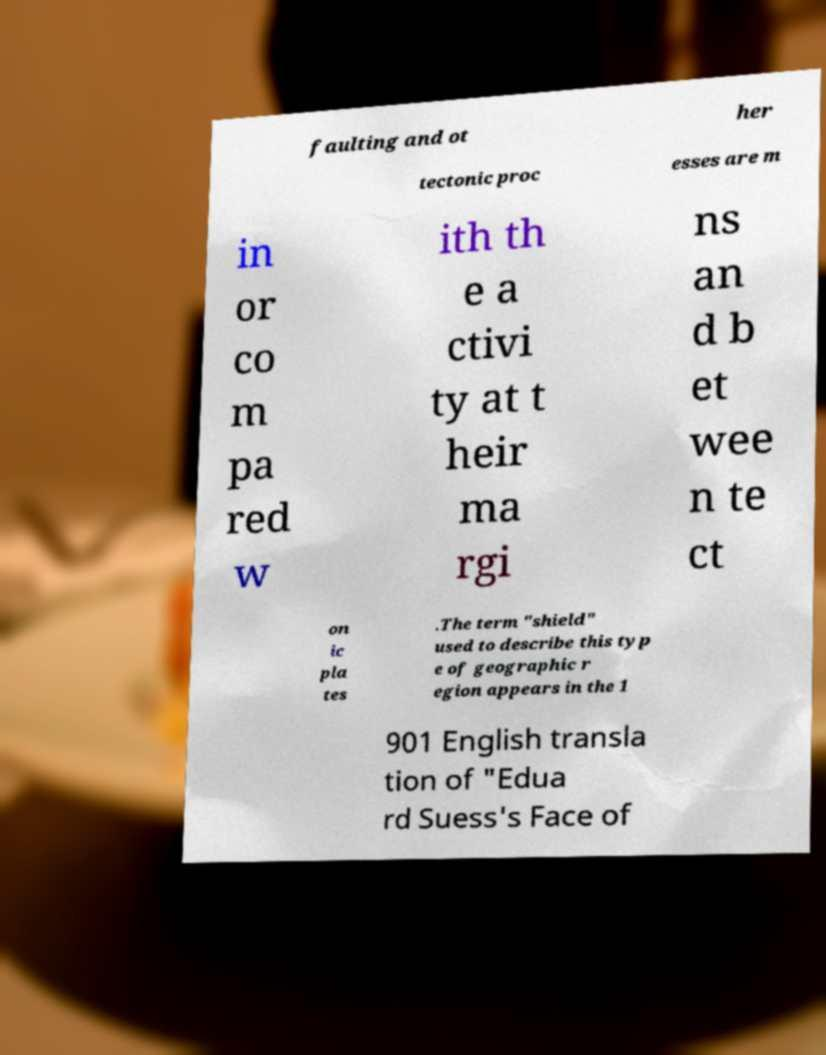There's text embedded in this image that I need extracted. Can you transcribe it verbatim? faulting and ot her tectonic proc esses are m in or co m pa red w ith th e a ctivi ty at t heir ma rgi ns an d b et wee n te ct on ic pla tes .The term "shield" used to describe this typ e of geographic r egion appears in the 1 901 English transla tion of "Edua rd Suess's Face of 